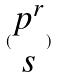<formula> <loc_0><loc_0><loc_500><loc_500>( \begin{matrix} p ^ { r } \\ s \end{matrix} )</formula> 